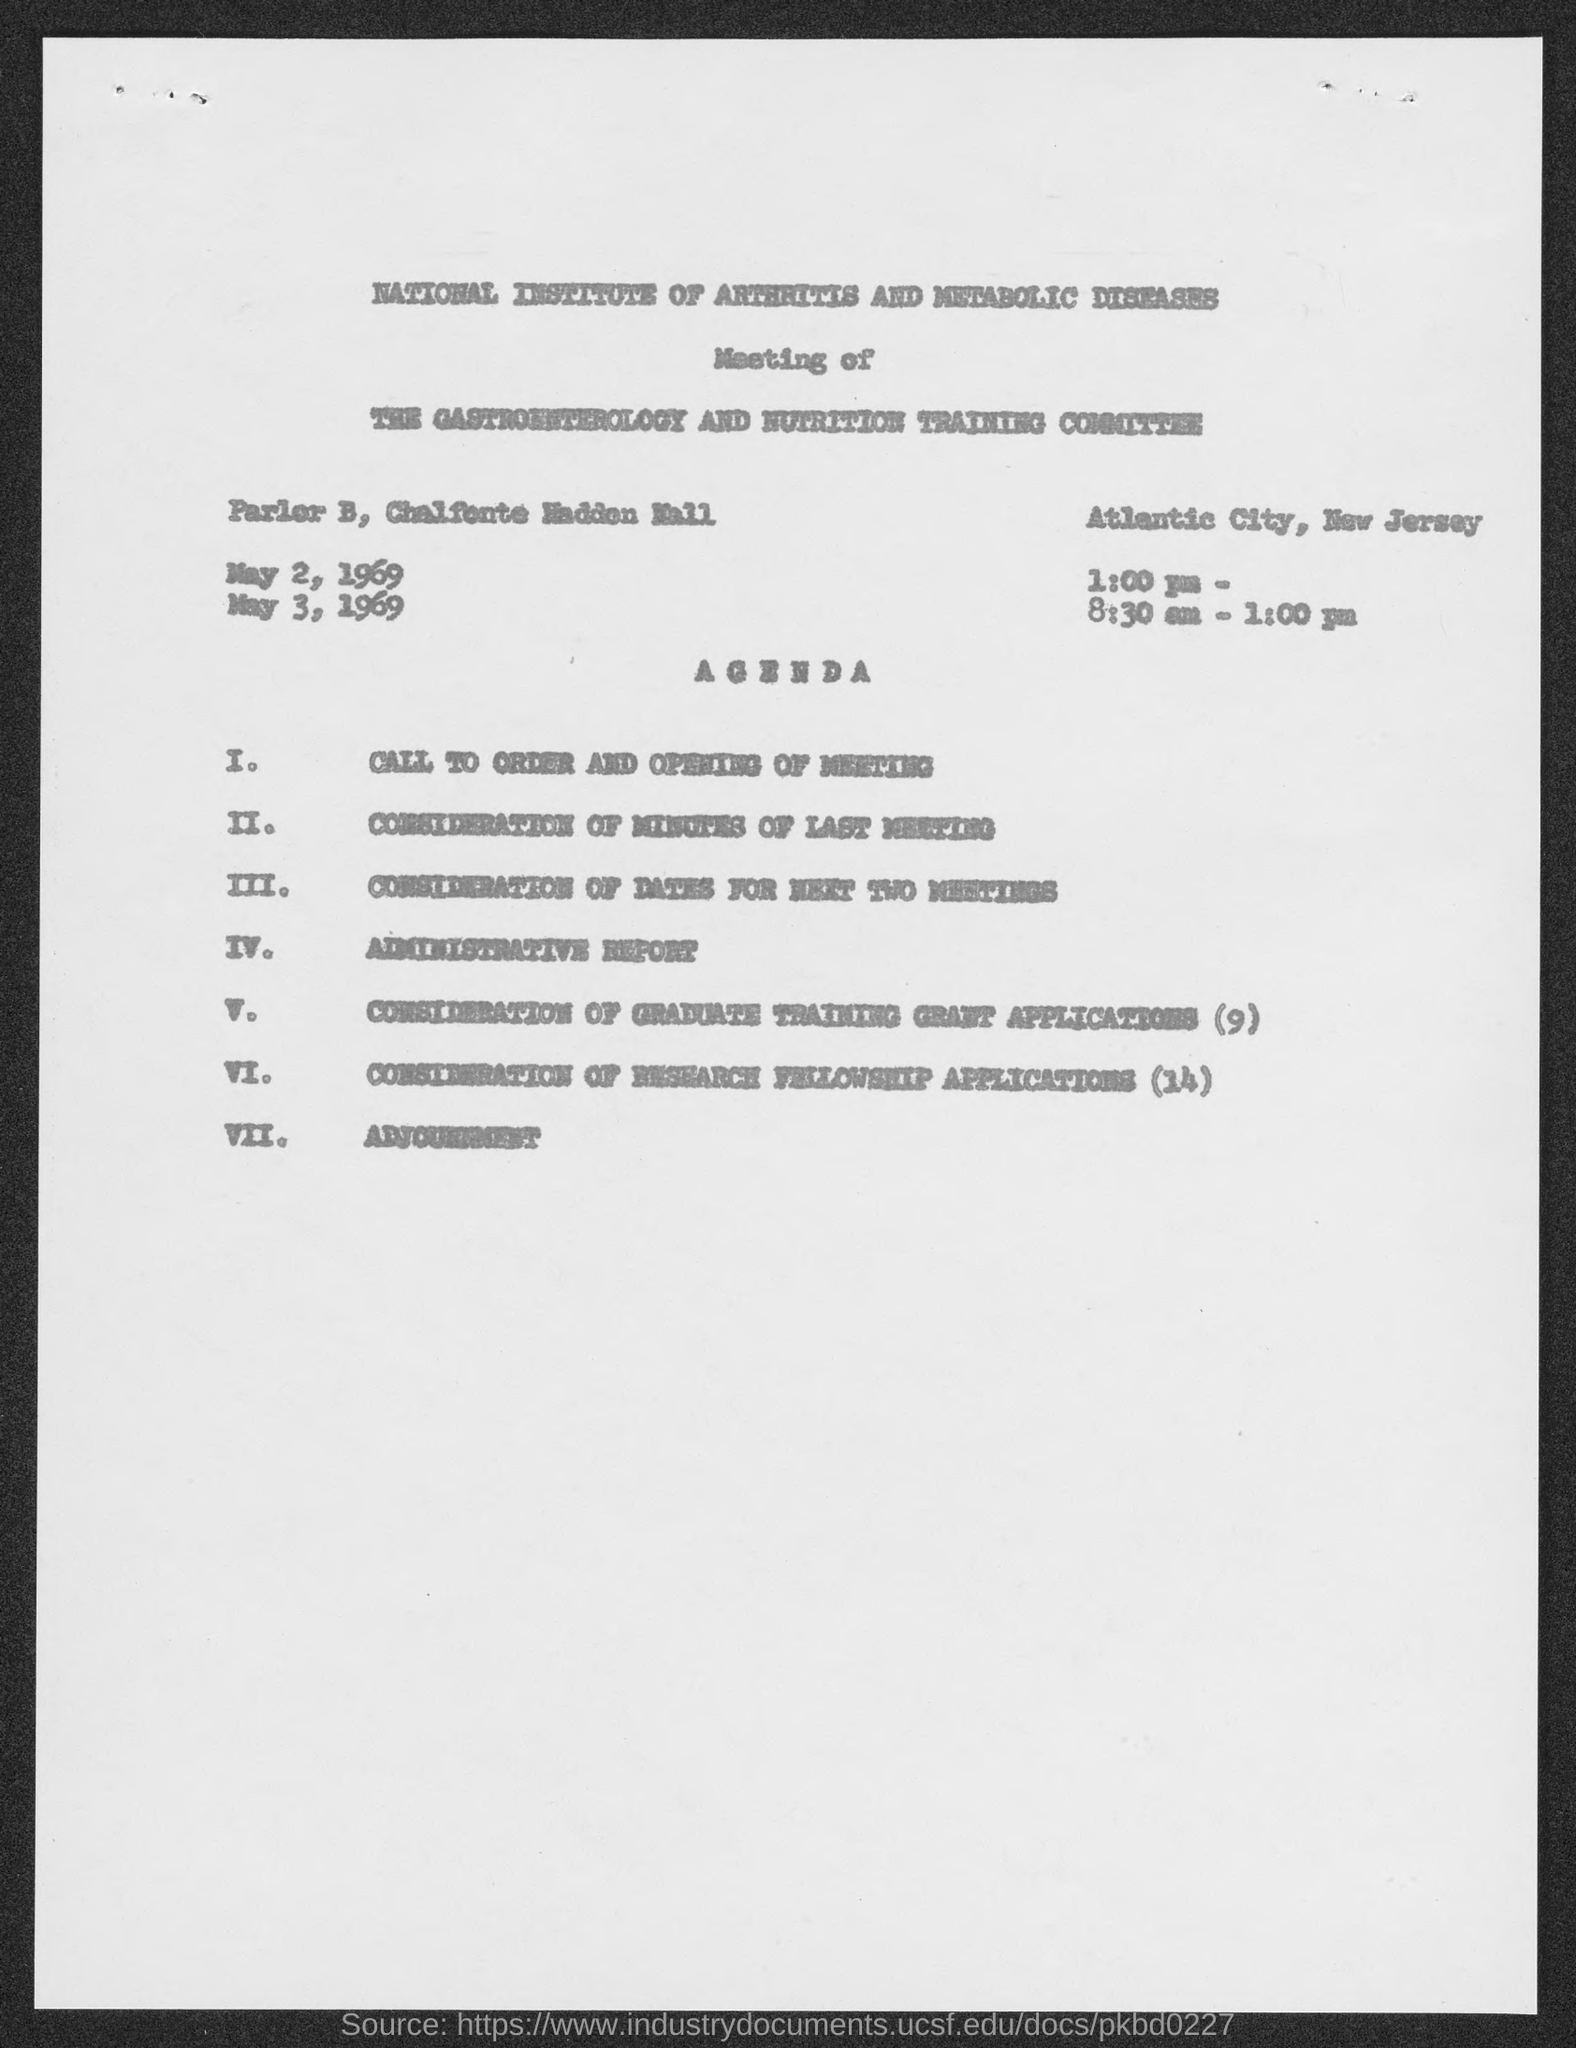Specify some key components in this picture. The Agenda item for VII is adjournment. The National Institute of Arthritis and Metabolic Diseases is the first title in the document. 